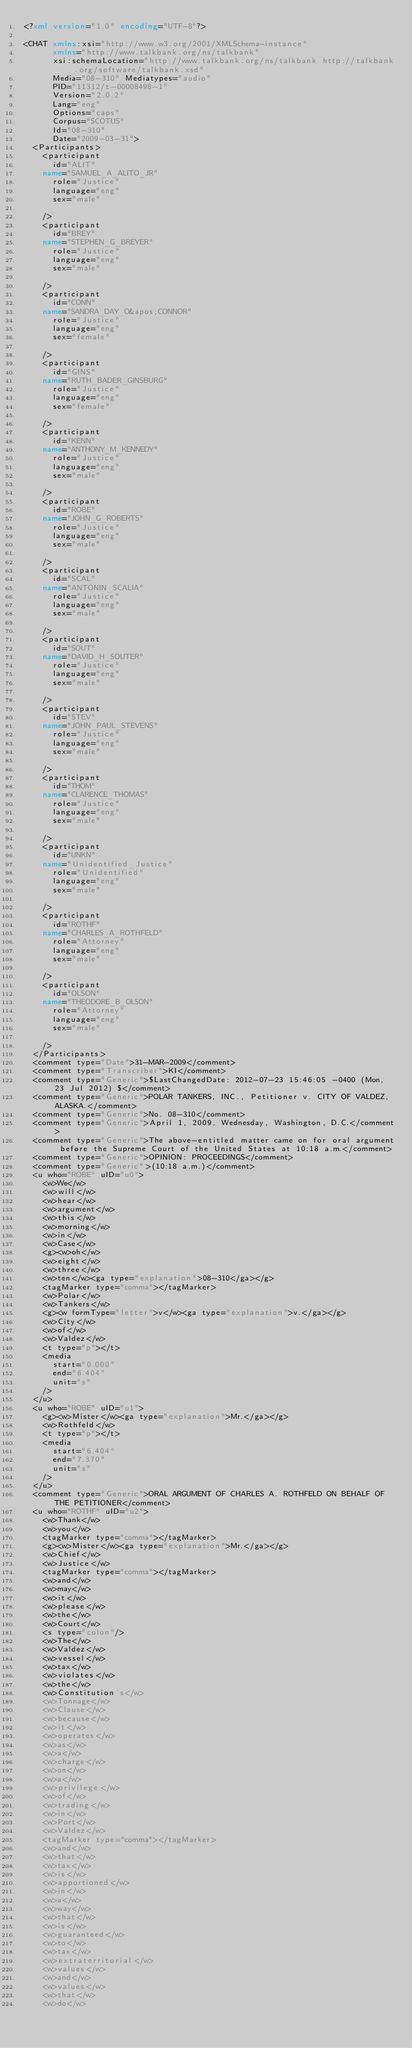Convert code to text. <code><loc_0><loc_0><loc_500><loc_500><_XML_><?xml version="1.0" encoding="UTF-8"?>

<CHAT xmlns:xsi="http://www.w3.org/2001/XMLSchema-instance"
      xmlns="http://www.talkbank.org/ns/talkbank"
      xsi:schemaLocation="http://www.talkbank.org/ns/talkbank http://talkbank.org/software/talkbank.xsd"
      Media="08-310" Mediatypes="audio"
      PID="11312/t-00008498-1"
      Version="2.0.2"
      Lang="eng"
      Options="caps"
      Corpus="SCOTUS"
      Id="08-310"
      Date="2009-03-31">
  <Participants>
    <participant
      id="ALIT"
    name="SAMUEL_A_ALITO_JR"
      role="Justice"
      language="eng"
      sex="male"

    />
    <participant
      id="BREY"
    name="STEPHEN_G_BREYER"
      role="Justice"
      language="eng"
      sex="male"

    />
    <participant
      id="CONN"
    name="SANDRA_DAY_O&apos;CONNOR"
      role="Justice"
      language="eng"
      sex="female"

    />
    <participant
      id="GINS"
    name="RUTH_BADER_GINSBURG"
      role="Justice"
      language="eng"
      sex="female"

    />
    <participant
      id="KENN"
    name="ANTHONY_M_KENNEDY"
      role="Justice"
      language="eng"
      sex="male"

    />
    <participant
      id="ROBE"
    name="JOHN_G_ROBERTS"
      role="Justice"
      language="eng"
      sex="male"

    />
    <participant
      id="SCAL"
    name="ANTONIN_SCALIA"
      role="Justice"
      language="eng"
      sex="male"

    />
    <participant
      id="SOUT"
    name="DAVID_H_SOUTER"
      role="Justice"
      language="eng"
      sex="male"

    />
    <participant
      id="STEV"
    name="JOHN_PAUL_STEVENS"
      role="Justice"
      language="eng"
      sex="male"

    />
    <participant
      id="THOM"
    name="CLARENCE_THOMAS"
      role="Justice"
      language="eng"
      sex="male"

    />
    <participant
      id="UNKN"
    name="Unidentified_Justice"
      role="Unidentified"
      language="eng"
      sex="male"

    />
    <participant
      id="ROTHF"
    name="CHARLES_A_ROTHFELD"
      role="Attorney"
      language="eng"
      sex="male"

    />
    <participant
      id="OLSON"
    name="THEODORE_B_OLSON"
      role="Attorney"
      language="eng"
      sex="male"

    />
  </Participants>
  <comment type="Date">31-MAR-2009</comment>
  <comment type="Transcriber">KI</comment>
  <comment type="Generic">$LastChangedDate: 2012-07-23 15:46:05 -0400 (Mon, 23 Jul 2012) $</comment>
  <comment type="Generic">POLAR TANKERS, INC., Petitioner v. CITY OF VALDEZ, ALASKA.</comment>
  <comment type="Generic">No. 08-310</comment>
  <comment type="Generic">April 1, 2009, Wednesday, Washington, D.C.</comment>
  <comment type="Generic">The above-entitled matter came on for oral argument before the Supreme Court of the United States at 10:18 a.m.</comment>
  <comment type="Generic">OPINION: PROCEEDINGS</comment>
  <comment type="Generic">(10:18 a.m.)</comment>
  <u who="ROBE" uID="u0">
    <w>We</w>
    <w>will</w>
    <w>hear</w>
    <w>argument</w>
    <w>this</w>
    <w>morning</w>
    <w>in</w>
    <w>Case</w>
    <g><w>oh</w>
    <w>eight</w>
    <w>three</w>
    <w>ten</w><ga type="explanation">08-310</ga></g>
    <tagMarker type="comma"></tagMarker>
    <w>Polar</w>
    <w>Tankers</w>
    <g><w formType="letter">v</w><ga type="explanation">v.</ga></g>
    <w>City</w>
    <w>of</w>
    <w>Valdez</w>
    <t type="p"></t>
    <media
      start="0.000"
      end="6.404"
      unit="s"
    />
  </u>
  <u who="ROBE" uID="u1">
    <g><w>Mister</w><ga type="explanation">Mr.</ga></g>
    <w>Rothfeld</w>
    <t type="p"></t>
    <media
      start="6.404"
      end="7.370"
      unit="s"
    />
  </u>
  <comment type="Generic">ORAL ARGUMENT OF CHARLES A. ROTHFELD ON BEHALF OF THE PETITIONER</comment>
  <u who="ROTHF" uID="u2">
    <w>Thank</w>
    <w>you</w>
    <tagMarker type="comma"></tagMarker>
    <g><w>Mister</w><ga type="explanation">Mr.</ga></g>
    <w>Chief</w>
    <w>Justice</w>
    <tagMarker type="comma"></tagMarker>
    <w>and</w>
    <w>may</w>
    <w>it</w>
    <w>please</w>
    <w>the</w>
    <w>Court</w>
    <s type="colon"/>
    <w>The</w>
    <w>Valdez</w>
    <w>vessel</w>
    <w>tax</w>
    <w>violates</w>
    <w>the</w>
    <w>Constitution's</w>
    <w>Tonnage</w>
    <w>Clause</w>
    <w>because</w>
    <w>it</w>
    <w>operates</w>
    <w>as</w>
    <w>a</w>
    <w>charge</w>
    <w>on</w>
    <w>a</w>
    <w>privilege</w>
    <w>of</w>
    <w>trading</w>
    <w>in</w>
    <w>Port</w>
    <w>Valdez</w>
    <tagMarker type="comma"></tagMarker>
    <w>and</w>
    <w>that</w>
    <w>tax</w>
    <w>is</w>
    <w>apportioned</w>
    <w>in</w>
    <w>a</w>
    <w>way</w>
    <w>that</w>
    <w>is</w>
    <w>guaranteed</w>
    <w>to</w>
    <w>tax</w>
    <w>extraterritorial</w>
    <w>values</w>
    <w>and</w>
    <w>values</w>
    <w>that</w>
    <w>do</w></code> 